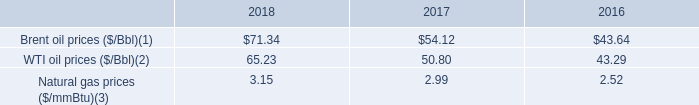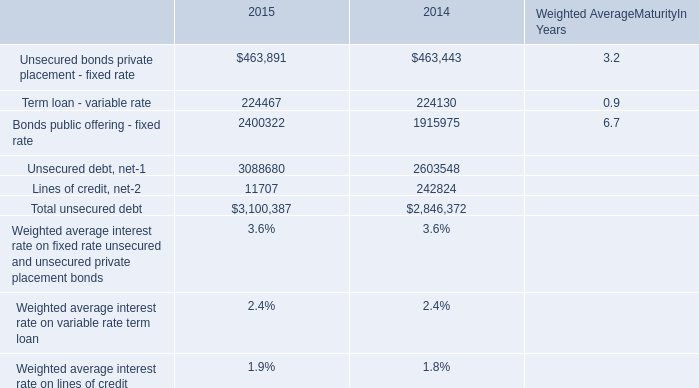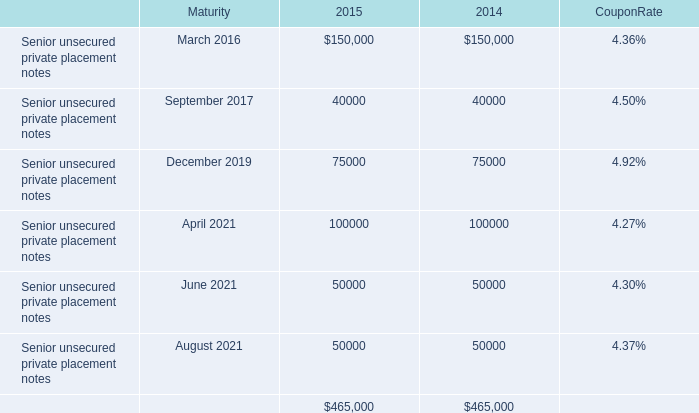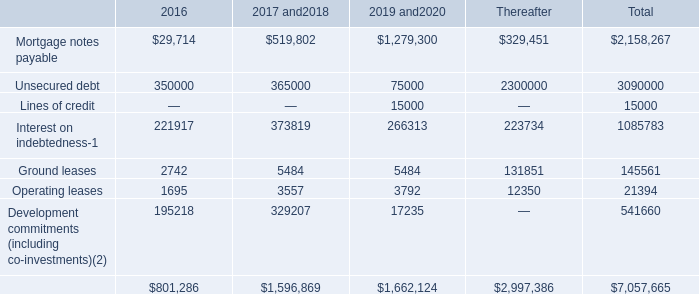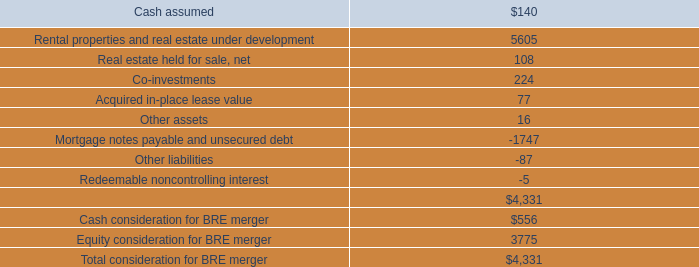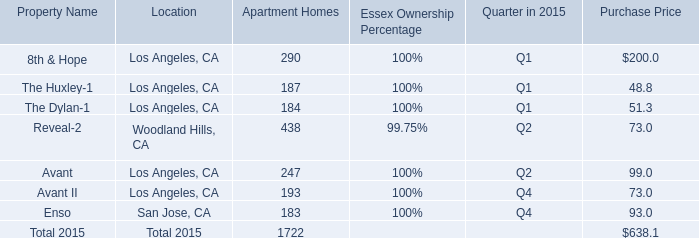What's the average of Unsecured debt, net of 2015, and Lines of credit of 2019 and2020 ? 
Computations: ((3088680.0 + 15000.0) / 2)
Answer: 1551840.0. 